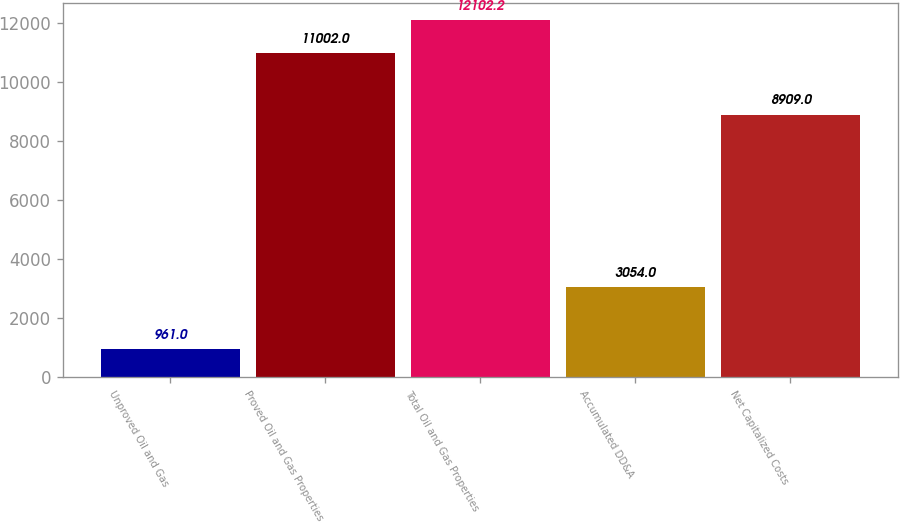Convert chart. <chart><loc_0><loc_0><loc_500><loc_500><bar_chart><fcel>Unproved Oil and Gas<fcel>Proved Oil and Gas Properties<fcel>Total Oil and Gas Properties<fcel>Accumulated DD&A<fcel>Net Capitalized Costs<nl><fcel>961<fcel>11002<fcel>12102.2<fcel>3054<fcel>8909<nl></chart> 